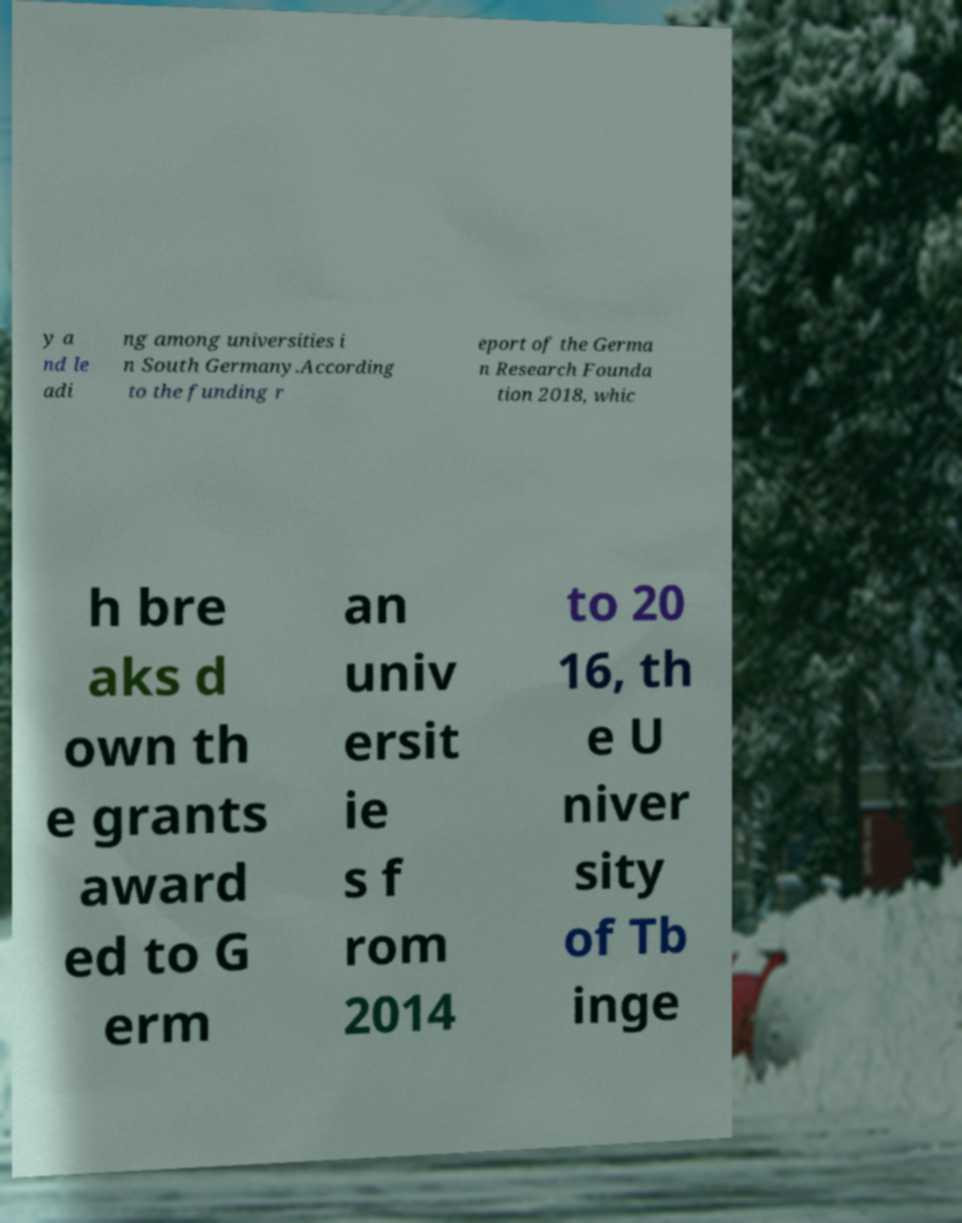Can you accurately transcribe the text from the provided image for me? y a nd le adi ng among universities i n South Germany.According to the funding r eport of the Germa n Research Founda tion 2018, whic h bre aks d own th e grants award ed to G erm an univ ersit ie s f rom 2014 to 20 16, th e U niver sity of Tb inge 